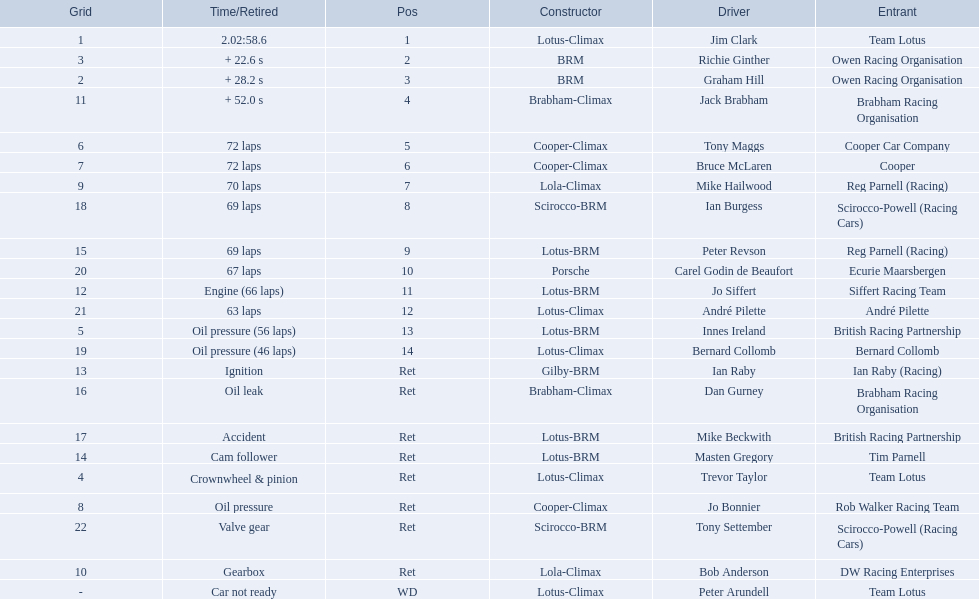Who were the drivers at the 1963 international gold cup? Jim Clark, Richie Ginther, Graham Hill, Jack Brabham, Tony Maggs, Bruce McLaren, Mike Hailwood, Ian Burgess, Peter Revson, Carel Godin de Beaufort, Jo Siffert, André Pilette, Innes Ireland, Bernard Collomb, Ian Raby, Dan Gurney, Mike Beckwith, Masten Gregory, Trevor Taylor, Jo Bonnier, Tony Settember, Bob Anderson, Peter Arundell. What was tony maggs position? 5. What was jo siffert? 11. Who came in earlier? Tony Maggs. 